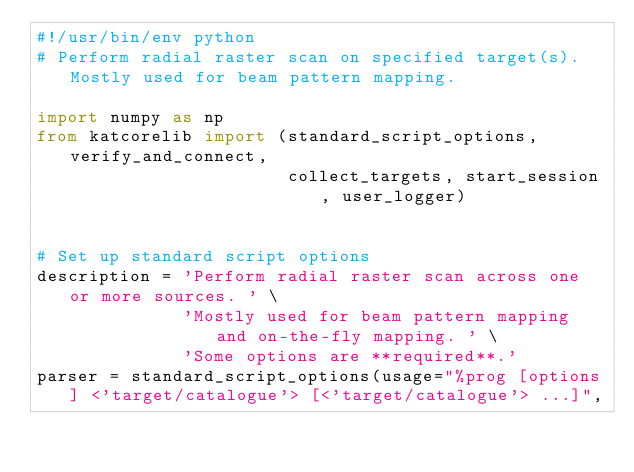<code> <loc_0><loc_0><loc_500><loc_500><_Python_>#!/usr/bin/env python
# Perform radial raster scan on specified target(s). Mostly used for beam pattern mapping.

import numpy as np
from katcorelib import (standard_script_options, verify_and_connect,
                        collect_targets, start_session, user_logger)


# Set up standard script options
description = 'Perform radial raster scan across one or more sources. ' \
              'Mostly used for beam pattern mapping and on-the-fly mapping. ' \
              'Some options are **required**.'
parser = standard_script_options(usage="%prog [options] <'target/catalogue'> [<'target/catalogue'> ...]",</code> 